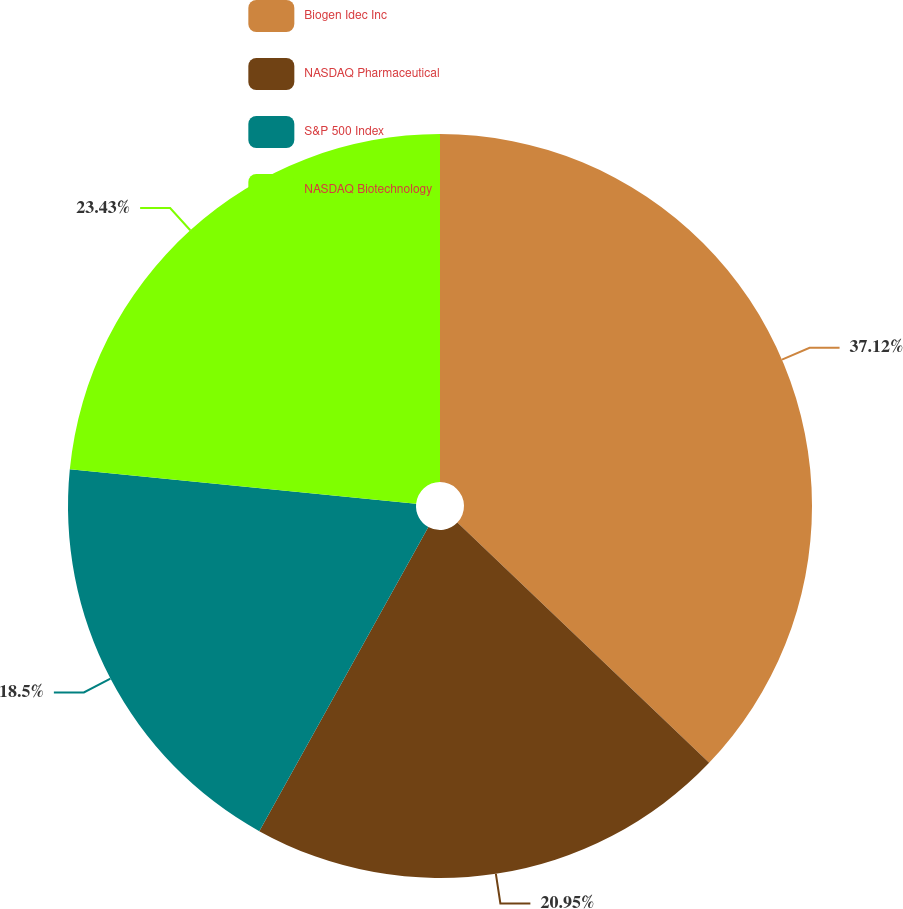Convert chart. <chart><loc_0><loc_0><loc_500><loc_500><pie_chart><fcel>Biogen Idec Inc<fcel>NASDAQ Pharmaceutical<fcel>S&P 500 Index<fcel>NASDAQ Biotechnology<nl><fcel>37.13%<fcel>20.95%<fcel>18.5%<fcel>23.43%<nl></chart> 